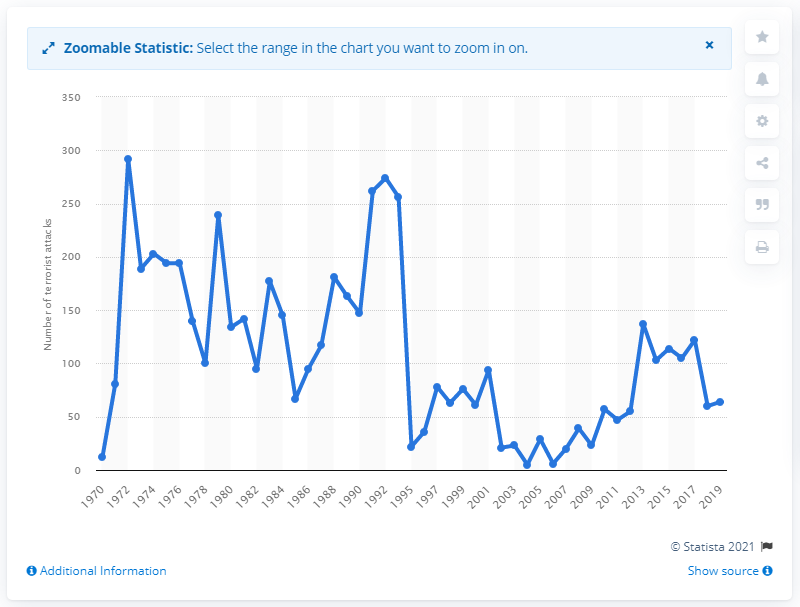Draw attention to some important aspects in this diagram. In 1972, the UK experienced the highest number of terrorist attacks. In 1972, there were 292 reported terrorist attacks. There were 64 terrorist attacks in the UK in 2019. 